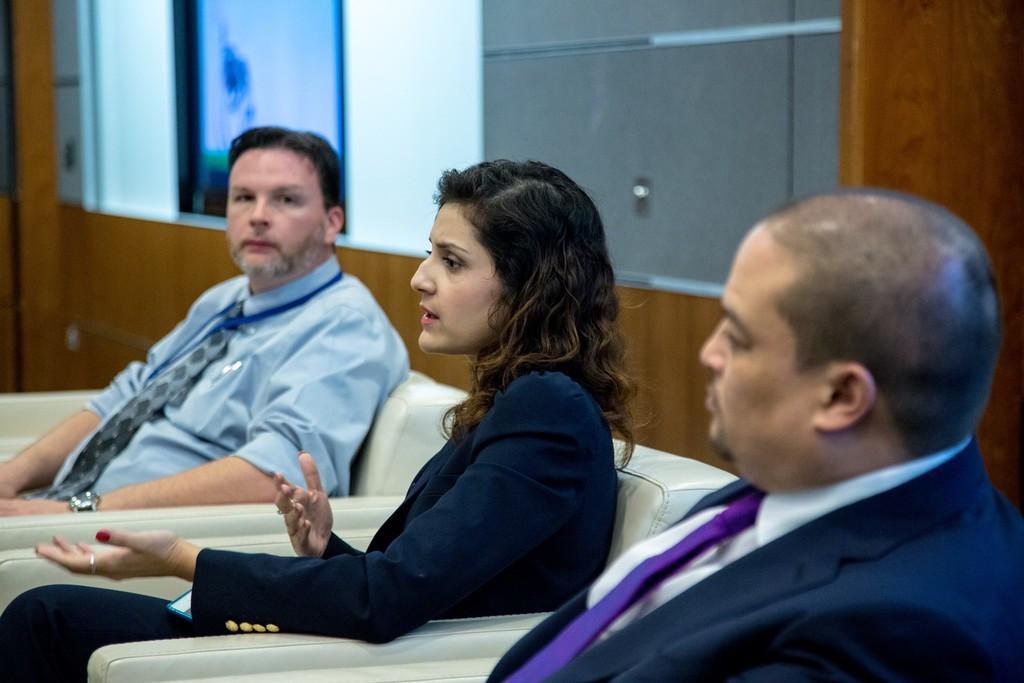Describe this image in one or two sentences. In this image I can see three people. These people are wearing the different color dresses. In the back I can see the brown color wall and there is a screen and some object to the wall. 